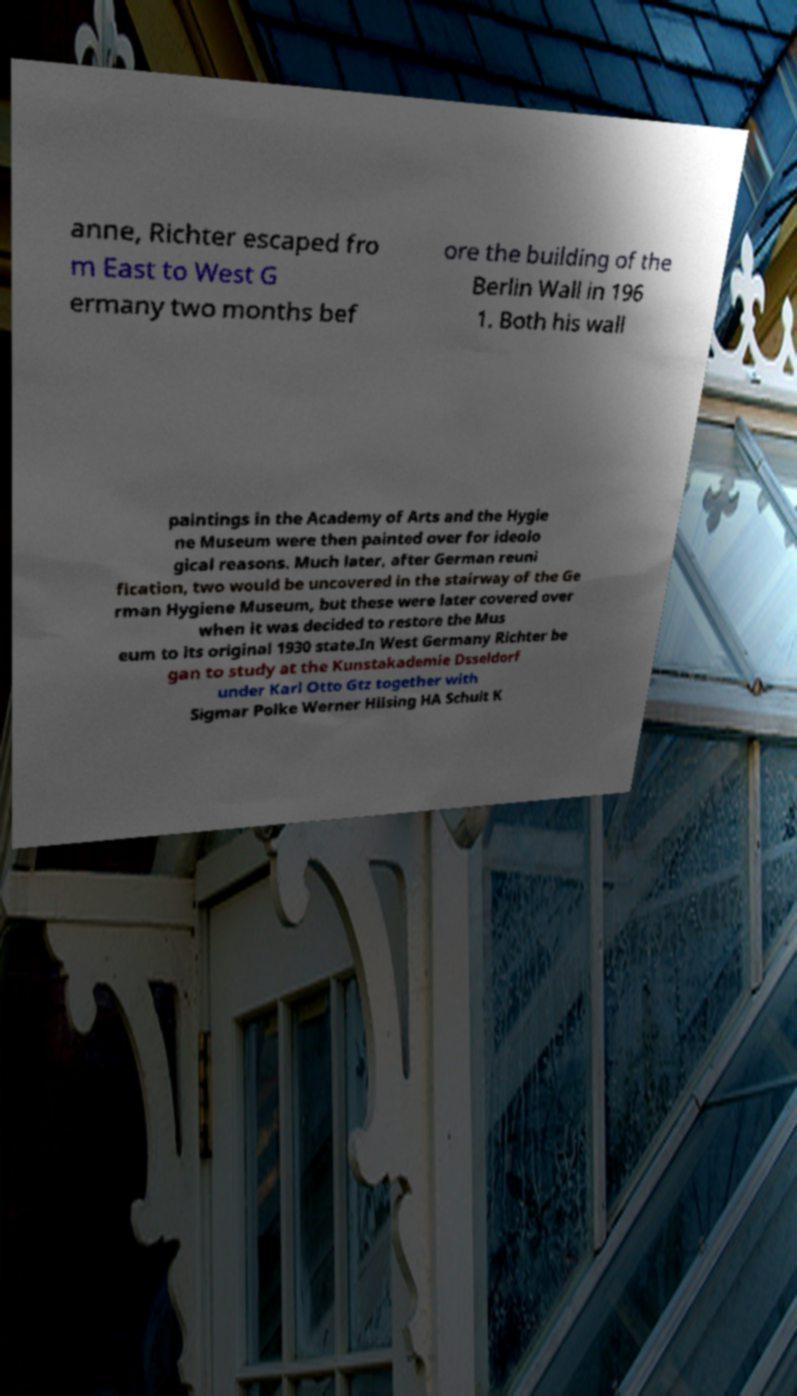Could you assist in decoding the text presented in this image and type it out clearly? anne, Richter escaped fro m East to West G ermany two months bef ore the building of the Berlin Wall in 196 1. Both his wall paintings in the Academy of Arts and the Hygie ne Museum were then painted over for ideolo gical reasons. Much later, after German reuni fication, two would be uncovered in the stairway of the Ge rman Hygiene Museum, but these were later covered over when it was decided to restore the Mus eum to its original 1930 state.In West Germany Richter be gan to study at the Kunstakademie Dsseldorf under Karl Otto Gtz together with Sigmar Polke Werner Hilsing HA Schult K 